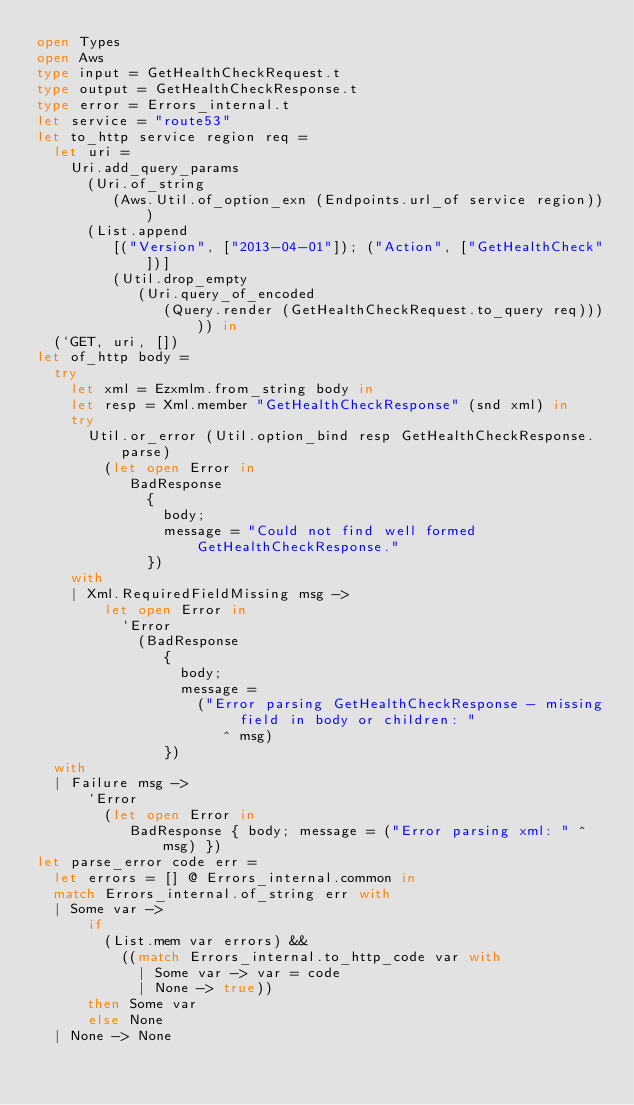Convert code to text. <code><loc_0><loc_0><loc_500><loc_500><_OCaml_>open Types
open Aws
type input = GetHealthCheckRequest.t
type output = GetHealthCheckResponse.t
type error = Errors_internal.t
let service = "route53"
let to_http service region req =
  let uri =
    Uri.add_query_params
      (Uri.of_string
         (Aws.Util.of_option_exn (Endpoints.url_of service region)))
      (List.append
         [("Version", ["2013-04-01"]); ("Action", ["GetHealthCheck"])]
         (Util.drop_empty
            (Uri.query_of_encoded
               (Query.render (GetHealthCheckRequest.to_query req))))) in
  (`GET, uri, [])
let of_http body =
  try
    let xml = Ezxmlm.from_string body in
    let resp = Xml.member "GetHealthCheckResponse" (snd xml) in
    try
      Util.or_error (Util.option_bind resp GetHealthCheckResponse.parse)
        (let open Error in
           BadResponse
             {
               body;
               message = "Could not find well formed GetHealthCheckResponse."
             })
    with
    | Xml.RequiredFieldMissing msg ->
        let open Error in
          `Error
            (BadResponse
               {
                 body;
                 message =
                   ("Error parsing GetHealthCheckResponse - missing field in body or children: "
                      ^ msg)
               })
  with
  | Failure msg ->
      `Error
        (let open Error in
           BadResponse { body; message = ("Error parsing xml: " ^ msg) })
let parse_error code err =
  let errors = [] @ Errors_internal.common in
  match Errors_internal.of_string err with
  | Some var ->
      if
        (List.mem var errors) &&
          ((match Errors_internal.to_http_code var with
            | Some var -> var = code
            | None -> true))
      then Some var
      else None
  | None -> None</code> 